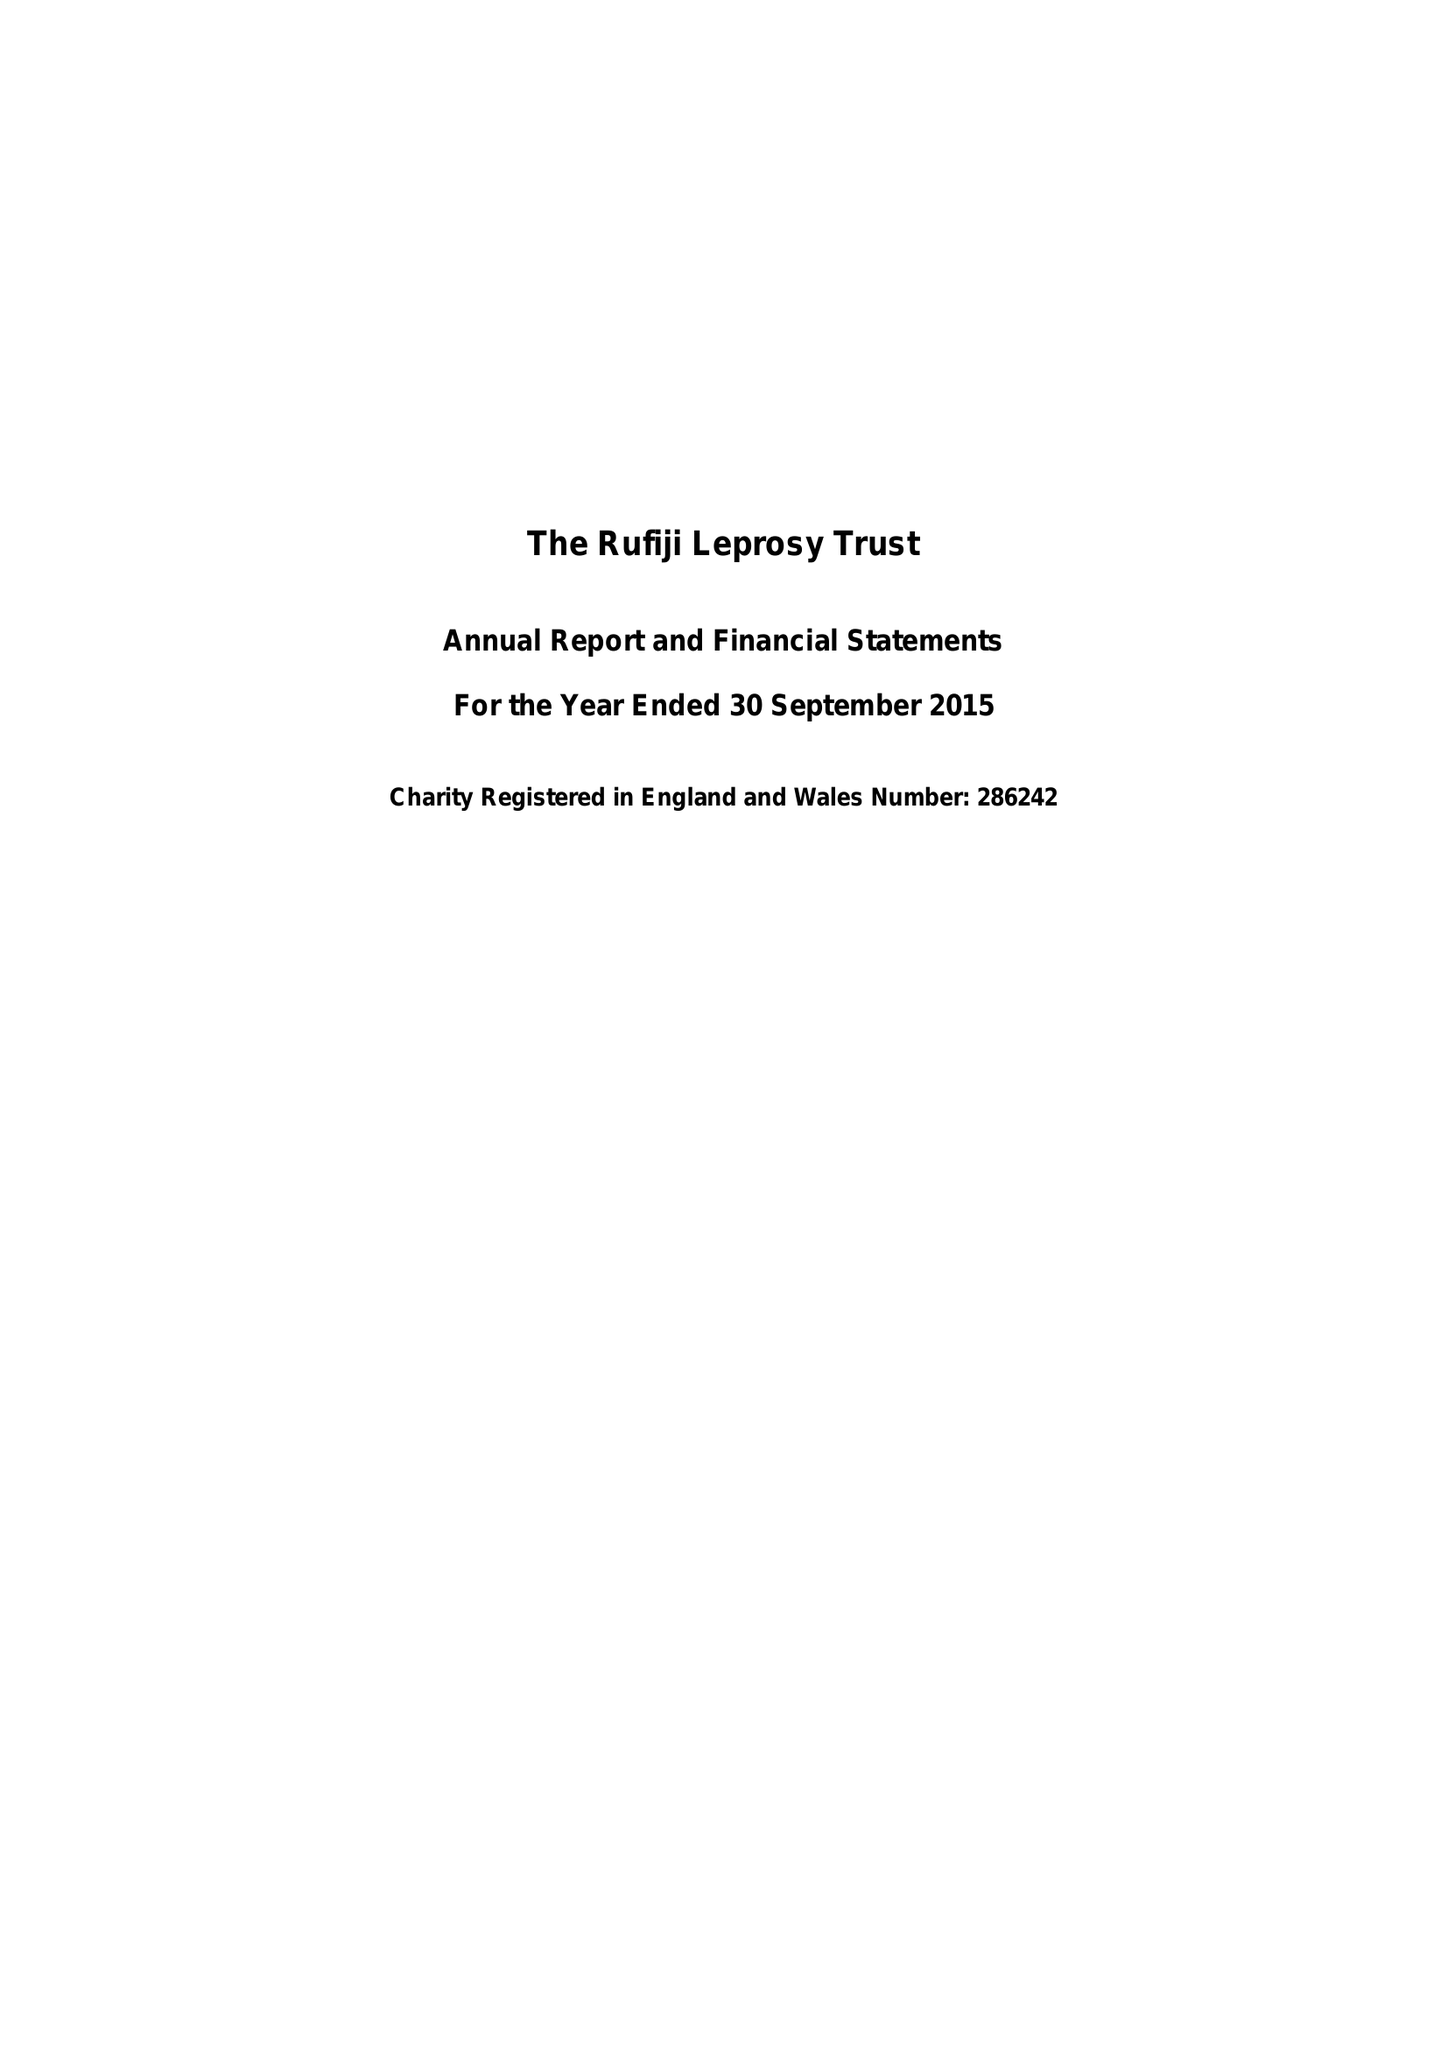What is the value for the address__post_town?
Answer the question using a single word or phrase. LONDON 